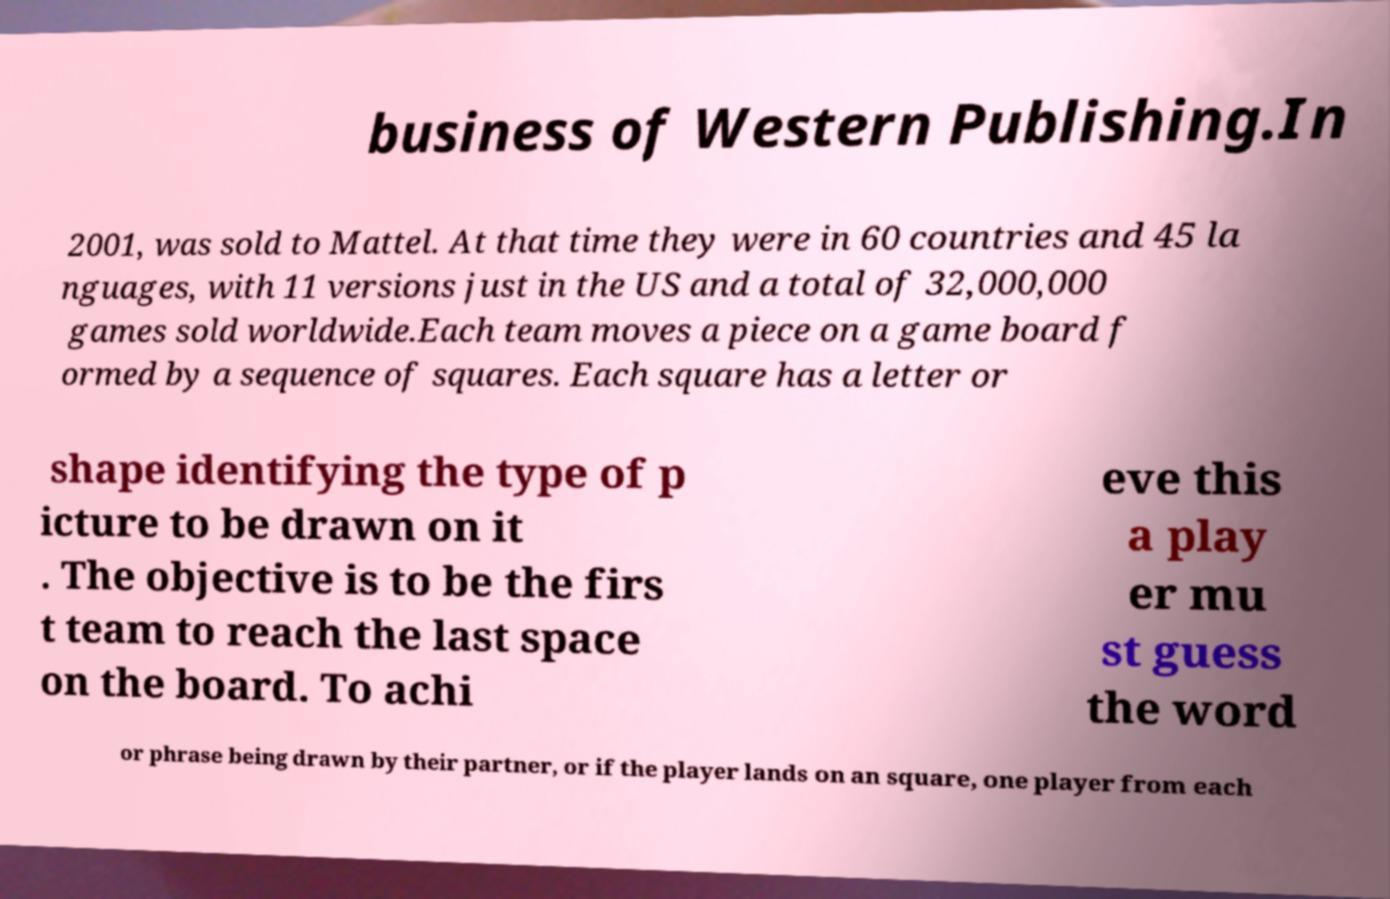Can you accurately transcribe the text from the provided image for me? business of Western Publishing.In 2001, was sold to Mattel. At that time they were in 60 countries and 45 la nguages, with 11 versions just in the US and a total of 32,000,000 games sold worldwide.Each team moves a piece on a game board f ormed by a sequence of squares. Each square has a letter or shape identifying the type of p icture to be drawn on it . The objective is to be the firs t team to reach the last space on the board. To achi eve this a play er mu st guess the word or phrase being drawn by their partner, or if the player lands on an square, one player from each 